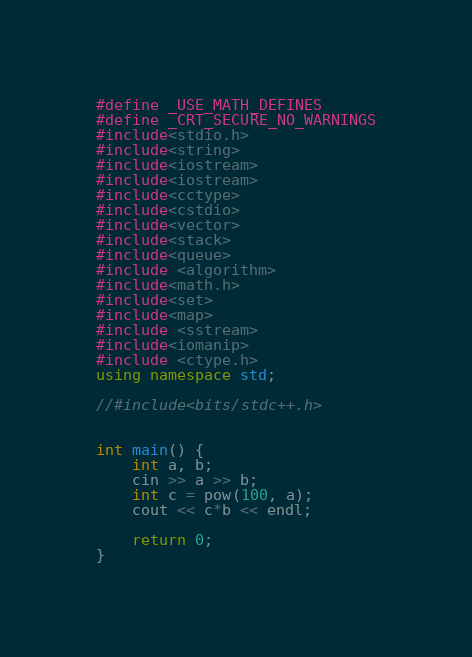Convert code to text. <code><loc_0><loc_0><loc_500><loc_500><_C++_>#define _USE_MATH_DEFINES
#define _CRT_SECURE_NO_WARNINGS
#include<stdio.h>
#include<string>
#include<iostream>
#include<iostream>
#include<cctype>
#include<cstdio>
#include<vector>
#include<stack>
#include<queue>
#include <algorithm>
#include<math.h>
#include<set>
#include<map>
#include <sstream>
#include<iomanip>
#include <ctype.h>
using namespace std;

//#include<bits/stdc++.h>


int main() {
	int a, b;
	cin >> a >> b;
	int c = pow(100, a);
	cout << c*b << endl;

	return 0;
}</code> 